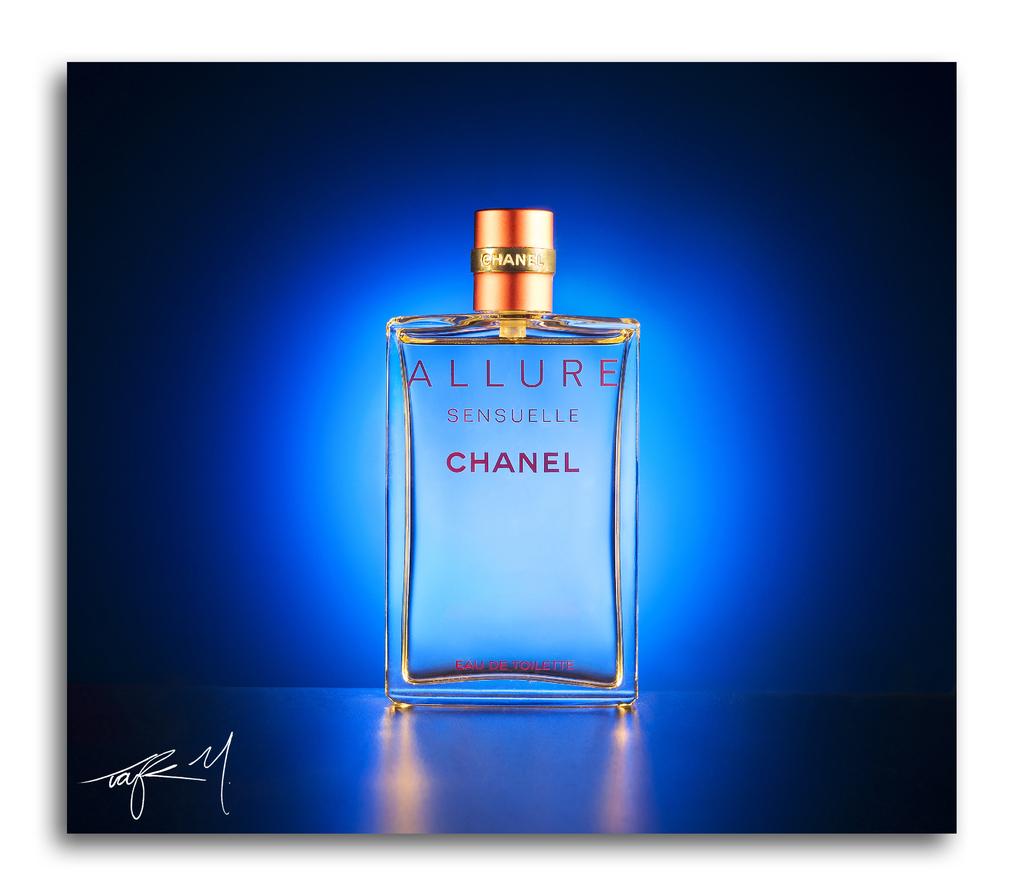Where can i buy this perfume?
Provide a succinct answer. Unanswerable. 